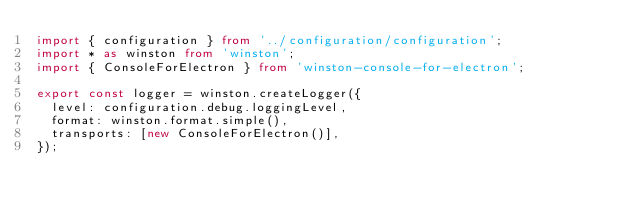<code> <loc_0><loc_0><loc_500><loc_500><_TypeScript_>import { configuration } from '../configuration/configuration';
import * as winston from 'winston';
import { ConsoleForElectron } from 'winston-console-for-electron';

export const logger = winston.createLogger({
  level: configuration.debug.loggingLevel,
  format: winston.format.simple(),
  transports: [new ConsoleForElectron()],
});
</code> 